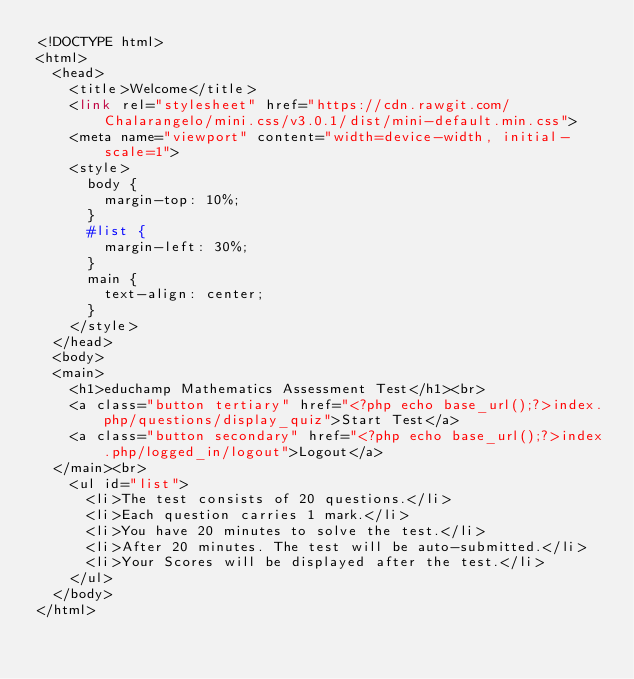Convert code to text. <code><loc_0><loc_0><loc_500><loc_500><_PHP_><!DOCTYPE html>
<html>
	<head>
		<title>Welcome</title>
		<link rel="stylesheet" href="https://cdn.rawgit.com/Chalarangelo/mini.css/v3.0.1/dist/mini-default.min.css">
		<meta name="viewport" content="width=device-width, initial-scale=1">
		<style>
			body {
				margin-top: 10%;
			}
			#list {
				margin-left: 30%;
			}
			main {
				text-align: center;
			}
		</style>
	</head>
	<body>
	<main>
		<h1>educhamp Mathematics Assessment Test</h1><br>
		<a class="button tertiary" href="<?php echo base_url();?>index.php/questions/display_quiz">Start Test</a>
		<a class="button secondary" href="<?php echo base_url();?>index.php/logged_in/logout">Logout</a>
	</main><br>	
		<ul id="list">
			<li>The test consists of 20 questions.</li>
			<li>Each question carries 1 mark.</li>
			<li>You have 20 minutes to solve the test.</li>
			<li>After 20 minutes. The test will be auto-submitted.</li>
			<li>Your Scores will be displayed after the test.</li>
		</ul>
	</body>
</html></code> 